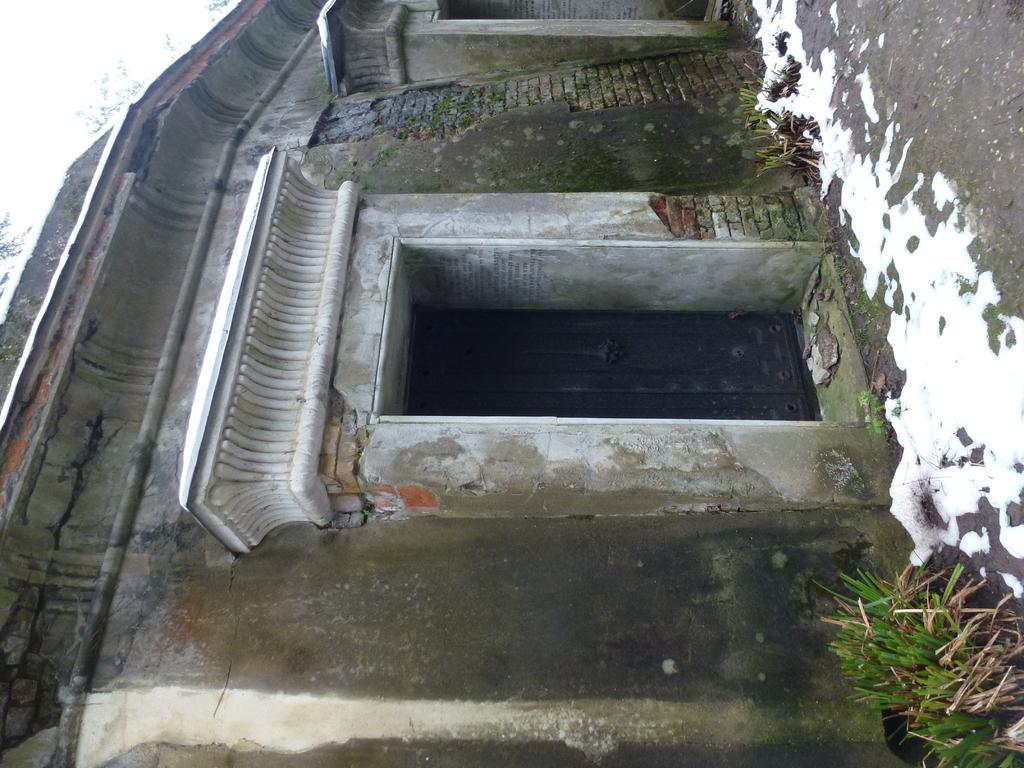Please provide a concise description of this image. In this picture I can see a building in front and on the right side of this picture, I can see few plants and I can see the snow on the ground. 